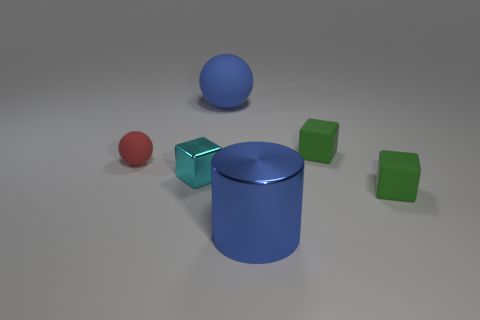What number of other things are there of the same color as the big sphere?
Your answer should be compact. 1. How many objects are small cubes behind the tiny red rubber object or matte things that are behind the cyan metal cube?
Your answer should be very brief. 3. What is the size of the green thing that is left of the rubber block that is in front of the cyan thing?
Provide a short and direct response. Small. How big is the blue metallic cylinder?
Provide a succinct answer. Large. There is a matte cube that is behind the red rubber thing; is it the same color as the tiny rubber block that is in front of the red object?
Give a very brief answer. Yes. What number of other objects are the same material as the blue cylinder?
Your answer should be very brief. 1. Is there a green shiny thing?
Keep it short and to the point. No. Does the green block that is in front of the tiny red thing have the same material as the cyan block?
Offer a very short reply. No. There is another thing that is the same shape as the large blue matte object; what is it made of?
Keep it short and to the point. Rubber. There is a large sphere that is the same color as the big cylinder; what is its material?
Offer a very short reply. Rubber. 